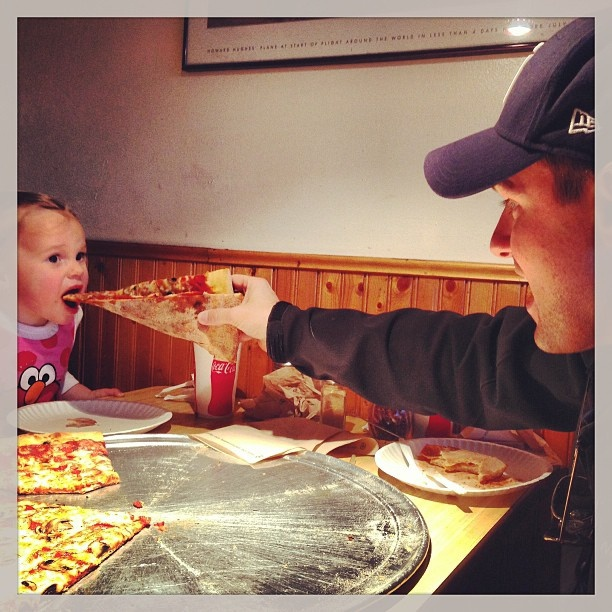Describe the objects in this image and their specific colors. I can see people in darkgray, black, maroon, brown, and purple tones, pizza in darkgray, tan, khaki, and lightyellow tones, people in darkgray, brown, and salmon tones, dining table in darkgray, khaki, maroon, brown, and lightyellow tones, and sandwich in darkgray, tan, brown, and salmon tones in this image. 